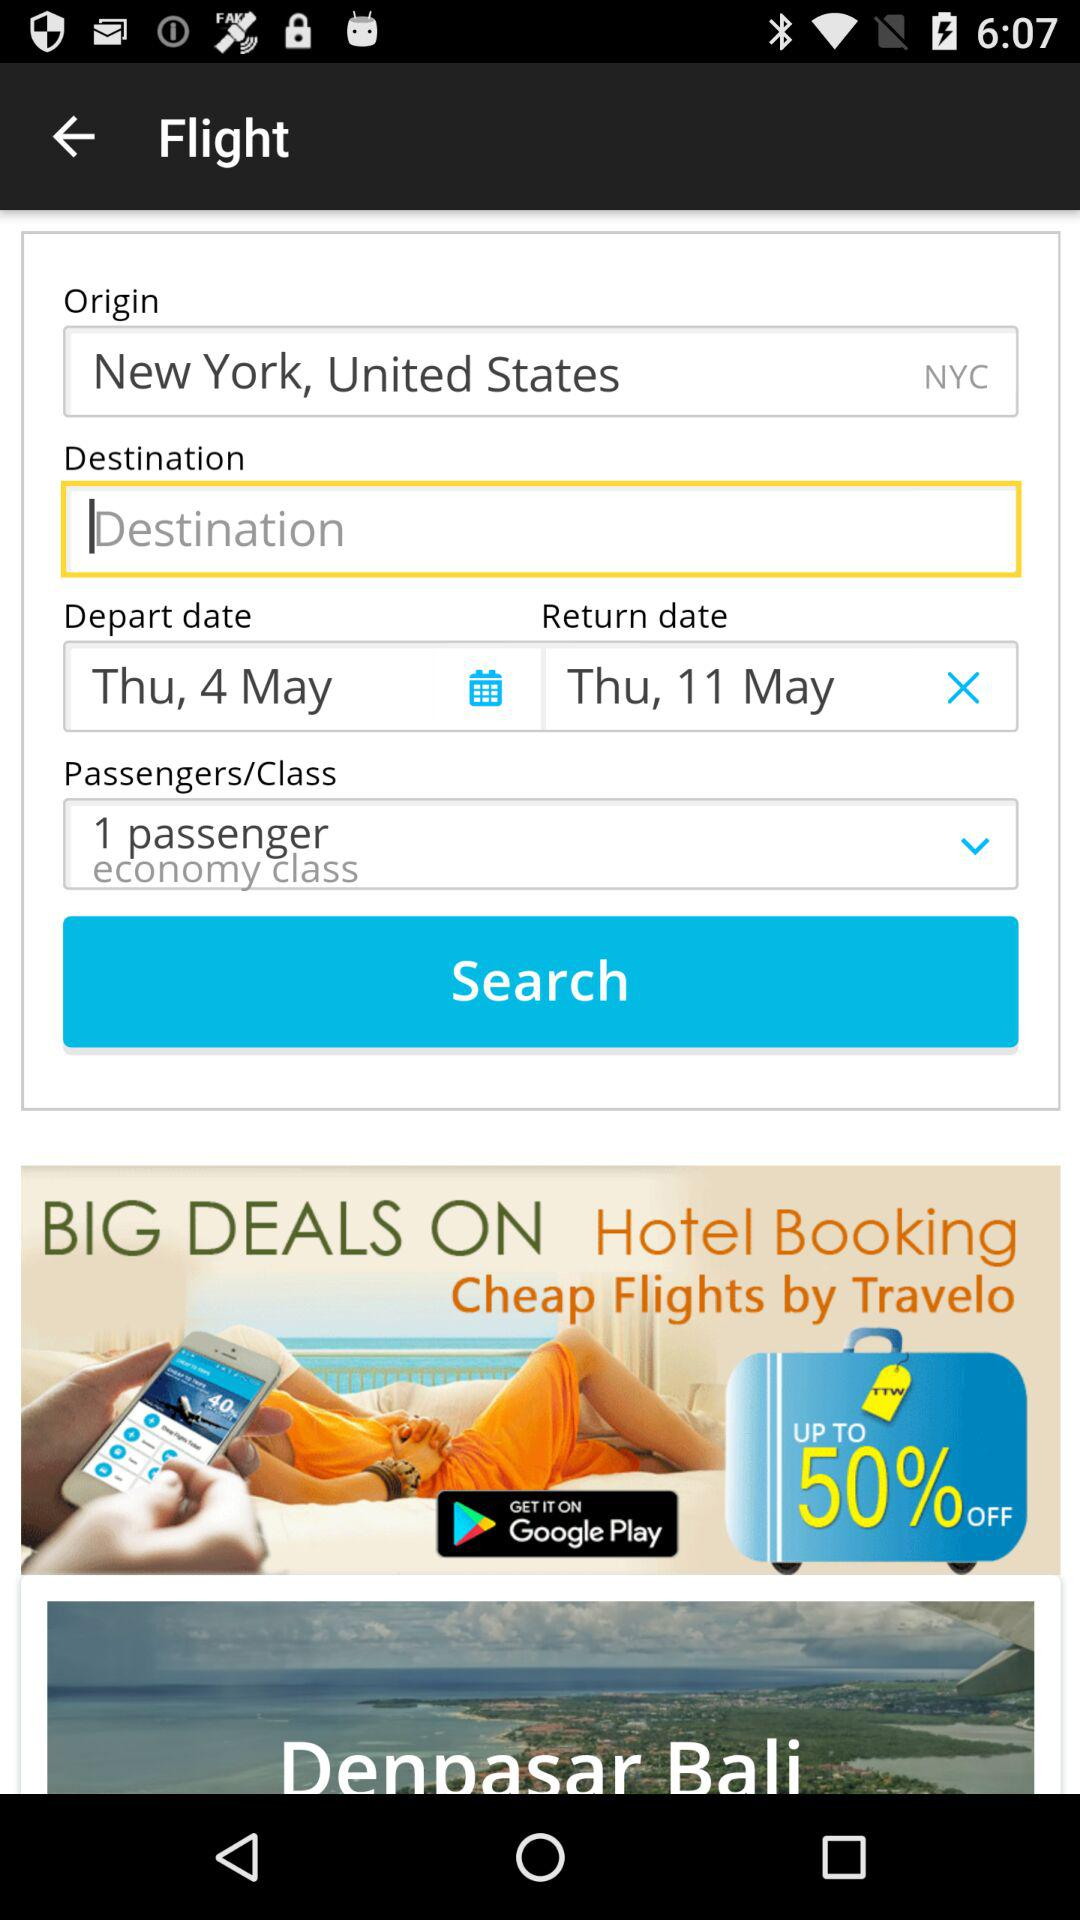How many passengers are there in this flight search?
Answer the question using a single word or phrase. 1 